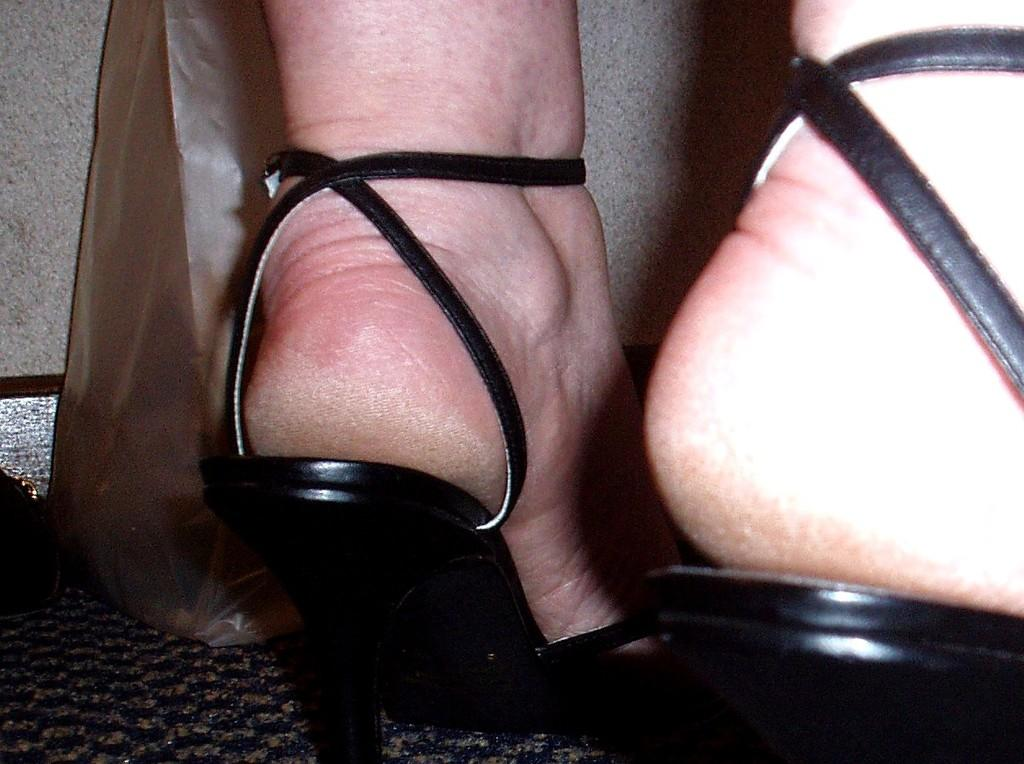What part of a person can be seen in the image? There are legs of a person visible in the image. What object is on the floor in the image? There is a bag on the floor in the image. Can you describe the setting of the image? The image may have been taken in a room. What type of detail can be seen on the monkey's fur in the image? There is no monkey present in the image, so there are no details to observe on its fur. 